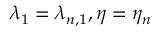Convert formula to latex. <formula><loc_0><loc_0><loc_500><loc_500>\lambda _ { 1 } = \lambda _ { n , 1 } , \eta = \eta _ { n }</formula> 